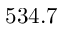<formula> <loc_0><loc_0><loc_500><loc_500>5 3 4 . 7</formula> 